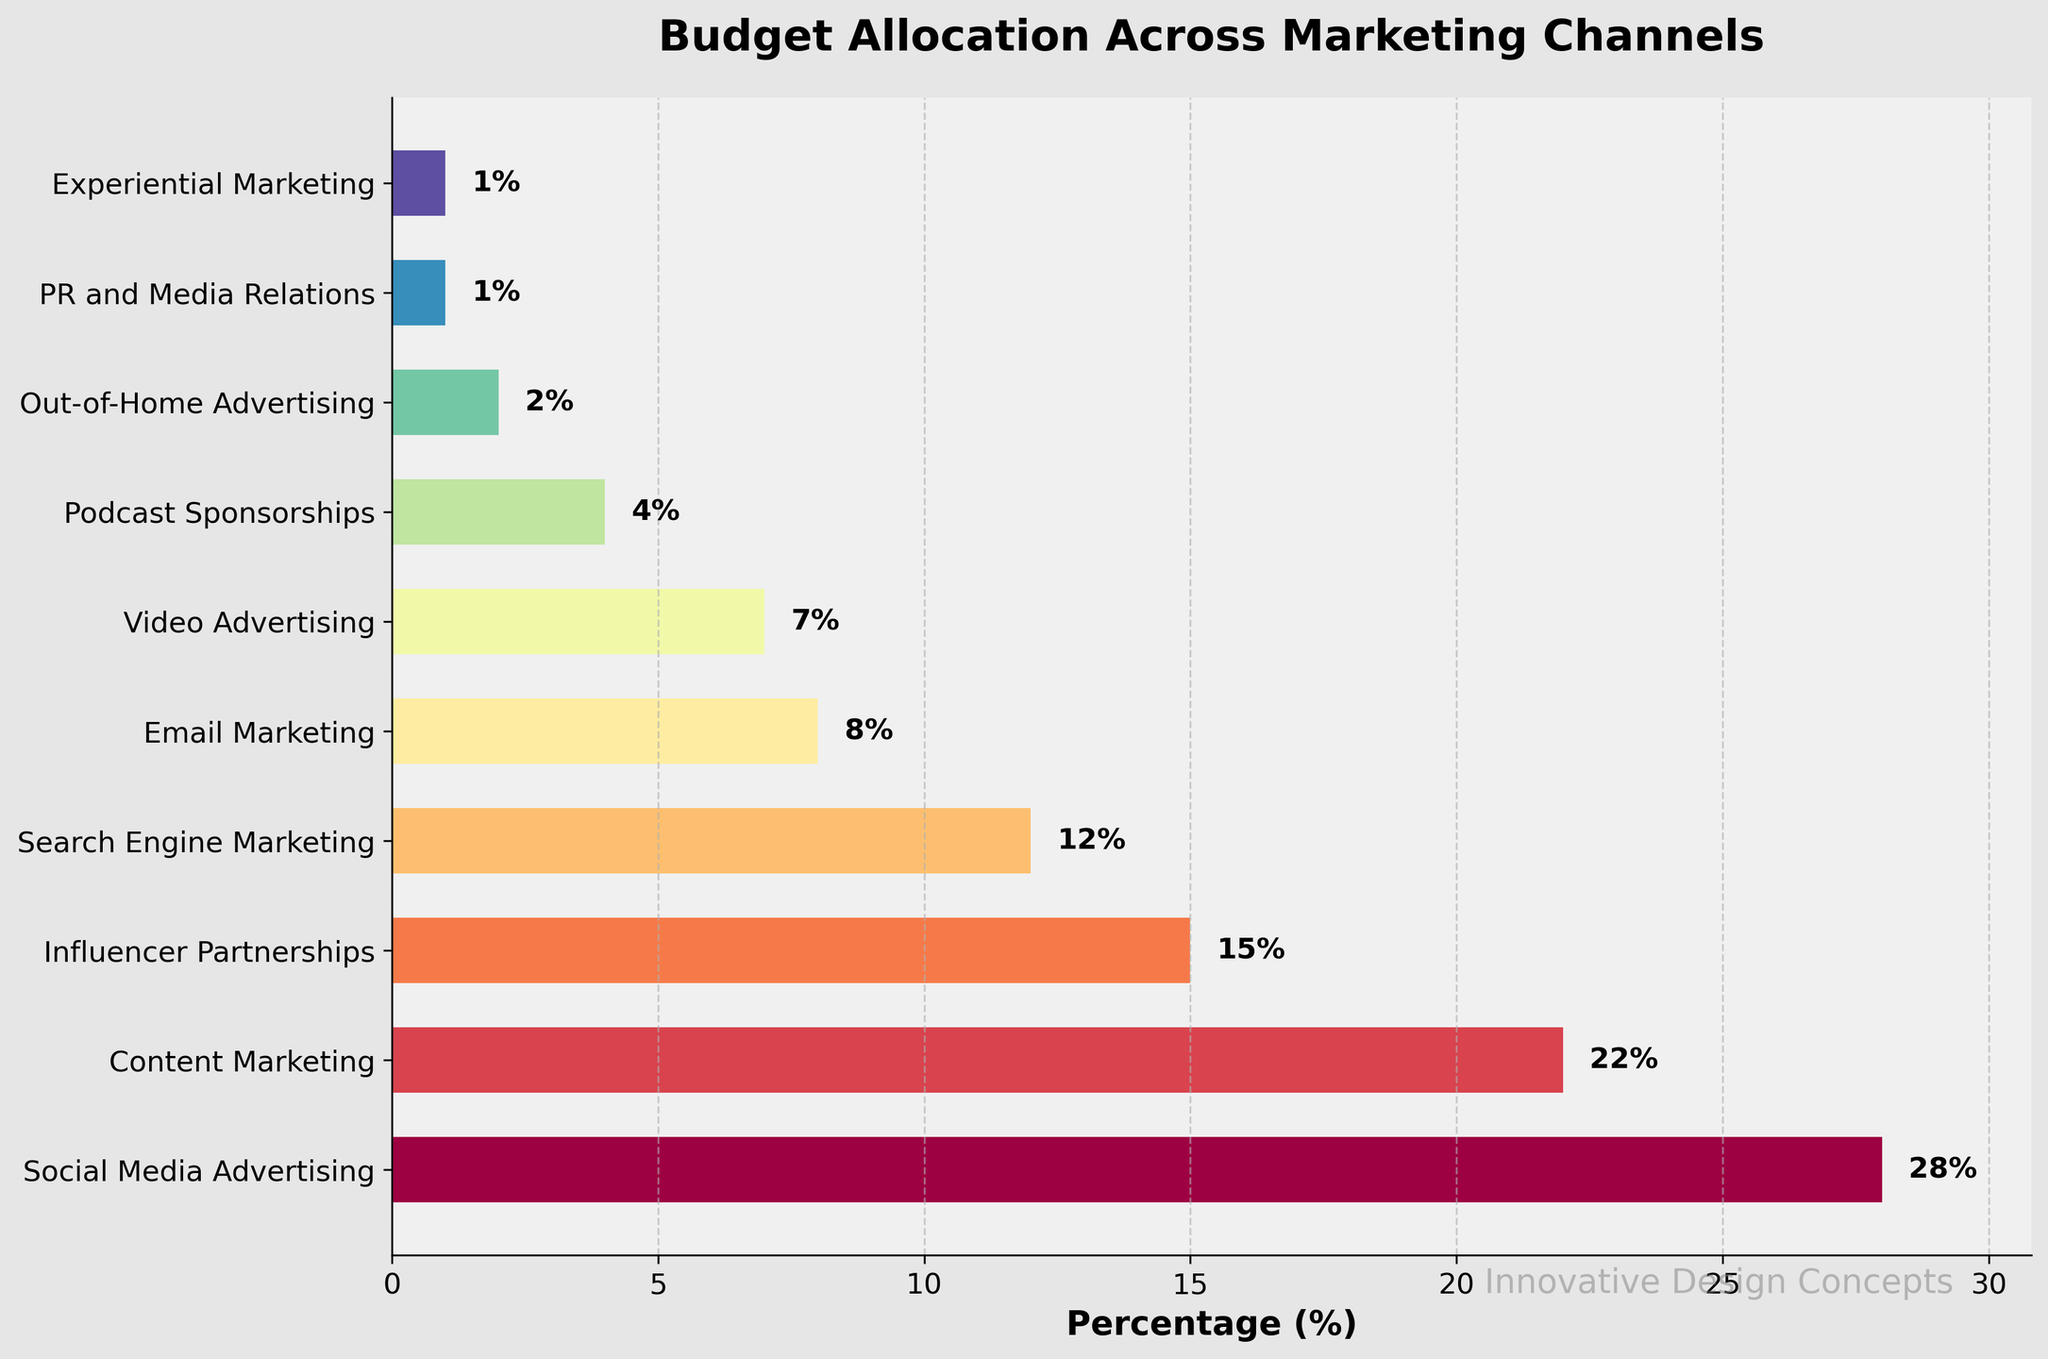What's the largest percentage of budget allocation? By looking at the figure, we can see that the longest bar, representing the largest percentage, is for Social Media Advertising. The percentage label on this bar shows 28%.
Answer: 28% Which marketing channel has the smallest budget allocation? The shortest bar in the chart represents the smallest budget allocation. This bar is for Experiential Marketing and PR and Media Relations, both with a percentage label showing 1%.
Answer: Experiential Marketing and PR and Media Relations What is the combined budget percentage for Search Engine Marketing and Email Marketing? By adding the percentages for Search Engine Marketing (12%) and Email Marketing (8%), we get 12% + 8% = 20%.
Answer: 20% Are there more resources allocated to Content Marketing or Video Advertising? By comparing the heights of the bars and the percentage labels, Content Marketing has 22% while Video Advertising has 7%. Therefore, more resources are allocated to Content Marketing.
Answer: Content Marketing Which marketing channel falls just below Influencer Partnerships in terms of budget allocation? By observing the figure, Influencer Partnerships have a 15% allocation. The next bar below is Search Engine Marketing at 12%.
Answer: Search Engine Marketing What percentage of the budget is allocated to podcast-related advertising combined (Podcast Sponsorships and Video Advertising)? Adding the percentages for Podcast Sponsorships (4%) and Video Advertising (7%), we get 4% + 7% = 11%.
Answer: 11% Which two categories have equal budget allocations? By examining the length of the bars and the percentage labels, Experiential Marketing and PR and Media Relations both have an allocation of 1%.
Answer: Experiential Marketing and PR and Media Relations How much more budget is allocated to Social Media Advertising compared to Email Marketing? Subtracting the percentage allocated to Email Marketing (8%) from Social Media Advertising (28%) yields 28% - 8% = 20%.
Answer: 20% Rank the top three marketing channels by budget allocation. By examining the bars' lengths and the associated percentages, the top three marketing channels are 1) Social Media Advertising (28%), 2) Content Marketing (22%), and 3) Influencer Partnerships (15%).
Answer: Social Media Advertising, Content Marketing, Influencer Partnerships 